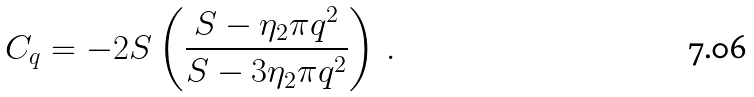<formula> <loc_0><loc_0><loc_500><loc_500>C _ { q } = - 2 S \left ( \frac { S - \eta _ { 2 } \pi q ^ { 2 } } { S - 3 \eta _ { 2 } \pi q ^ { 2 } } \right ) \, .</formula> 